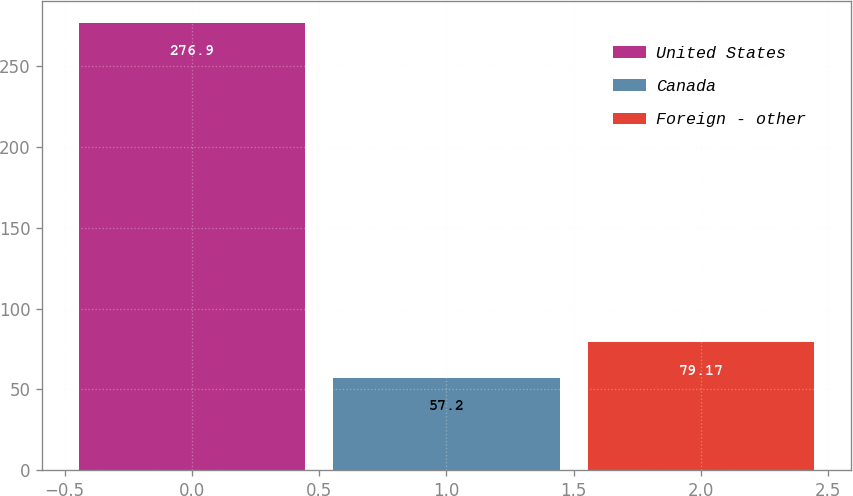<chart> <loc_0><loc_0><loc_500><loc_500><bar_chart><fcel>United States<fcel>Canada<fcel>Foreign - other<nl><fcel>276.9<fcel>57.2<fcel>79.17<nl></chart> 